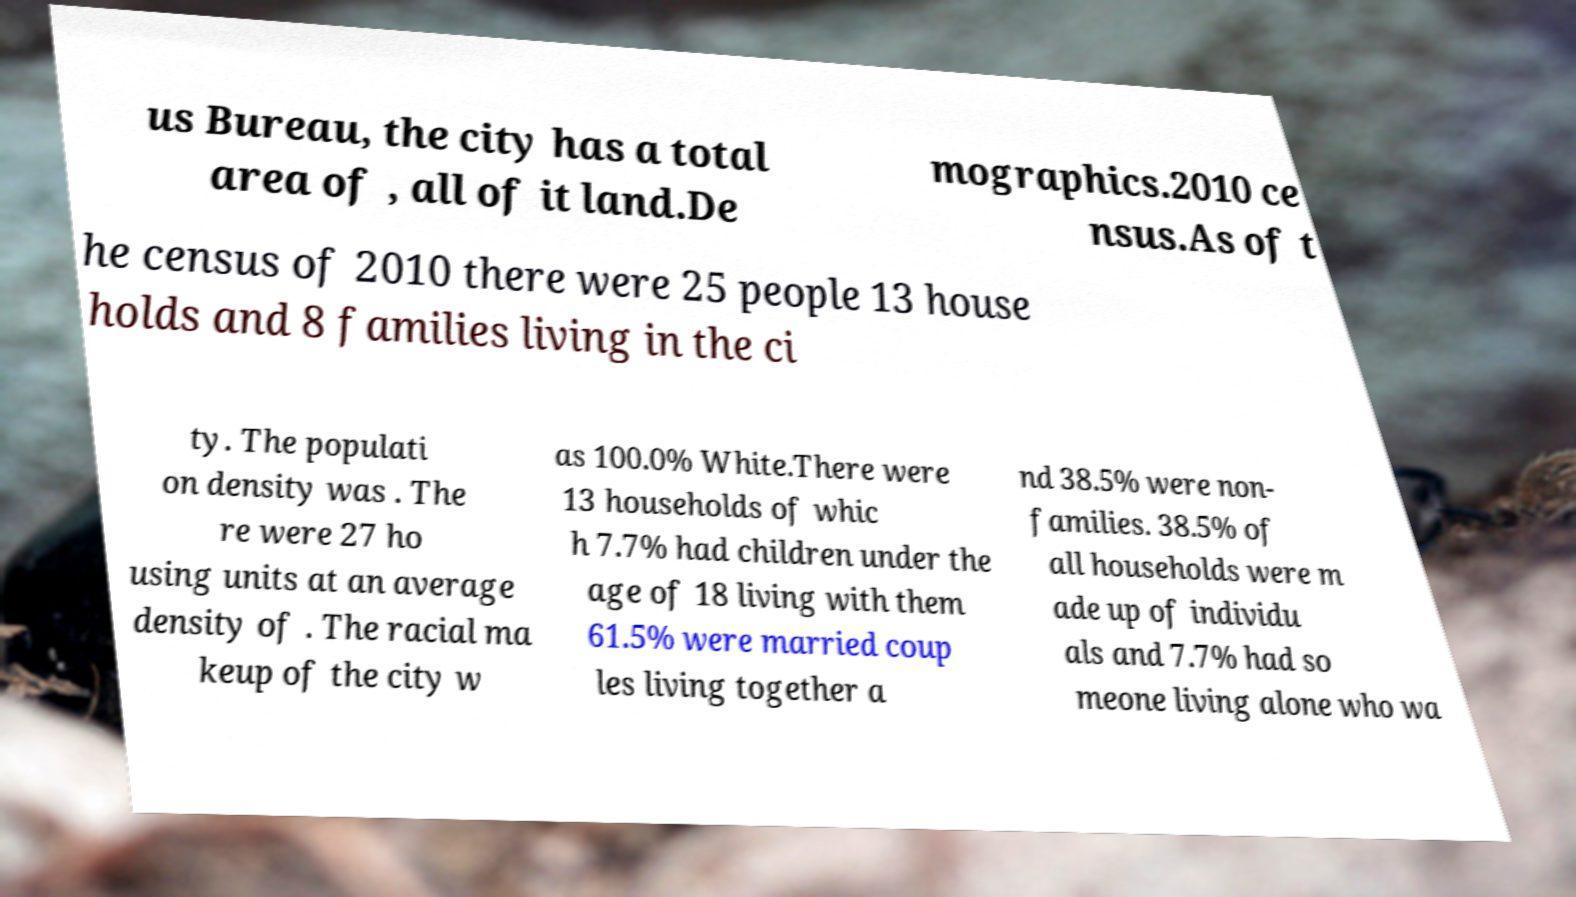Could you assist in decoding the text presented in this image and type it out clearly? us Bureau, the city has a total area of , all of it land.De mographics.2010 ce nsus.As of t he census of 2010 there were 25 people 13 house holds and 8 families living in the ci ty. The populati on density was . The re were 27 ho using units at an average density of . The racial ma keup of the city w as 100.0% White.There were 13 households of whic h 7.7% had children under the age of 18 living with them 61.5% were married coup les living together a nd 38.5% were non- families. 38.5% of all households were m ade up of individu als and 7.7% had so meone living alone who wa 